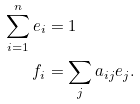Convert formula to latex. <formula><loc_0><loc_0><loc_500><loc_500>\sum _ { i = 1 } ^ { n } e _ { i } & = 1 \\ f _ { i } & = \sum _ { j } a _ { i j } e _ { j } .</formula> 